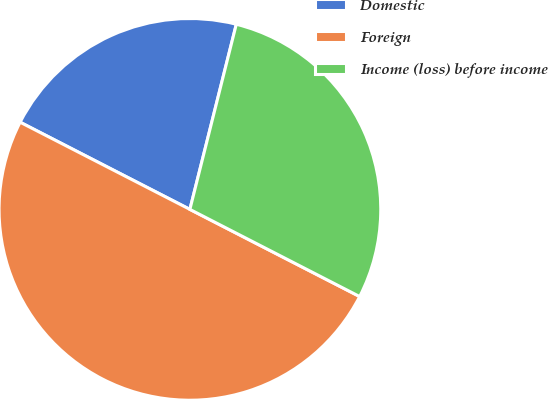Convert chart. <chart><loc_0><loc_0><loc_500><loc_500><pie_chart><fcel>Domestic<fcel>Foreign<fcel>Income (loss) before income<nl><fcel>21.36%<fcel>50.0%<fcel>28.64%<nl></chart> 